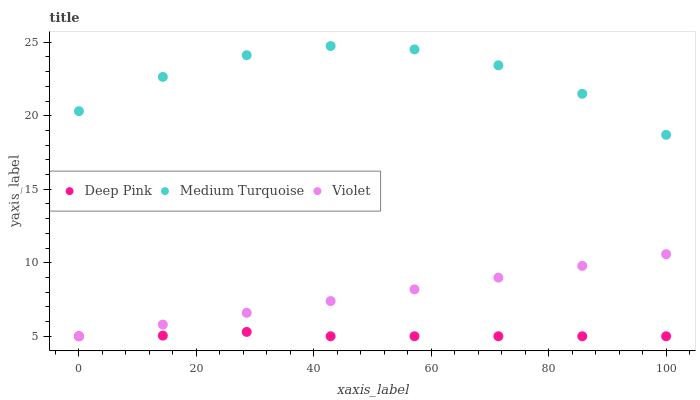Does Deep Pink have the minimum area under the curve?
Answer yes or no. Yes. Does Medium Turquoise have the maximum area under the curve?
Answer yes or no. Yes. Does Violet have the minimum area under the curve?
Answer yes or no. No. Does Violet have the maximum area under the curve?
Answer yes or no. No. Is Violet the smoothest?
Answer yes or no. Yes. Is Medium Turquoise the roughest?
Answer yes or no. Yes. Is Medium Turquoise the smoothest?
Answer yes or no. No. Is Violet the roughest?
Answer yes or no. No. Does Deep Pink have the lowest value?
Answer yes or no. Yes. Does Medium Turquoise have the lowest value?
Answer yes or no. No. Does Medium Turquoise have the highest value?
Answer yes or no. Yes. Does Violet have the highest value?
Answer yes or no. No. Is Violet less than Medium Turquoise?
Answer yes or no. Yes. Is Medium Turquoise greater than Violet?
Answer yes or no. Yes. Does Deep Pink intersect Violet?
Answer yes or no. Yes. Is Deep Pink less than Violet?
Answer yes or no. No. Is Deep Pink greater than Violet?
Answer yes or no. No. Does Violet intersect Medium Turquoise?
Answer yes or no. No. 